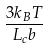Convert formula to latex. <formula><loc_0><loc_0><loc_500><loc_500>\frac { 3 k _ { B } T } { L _ { c } b }</formula> 